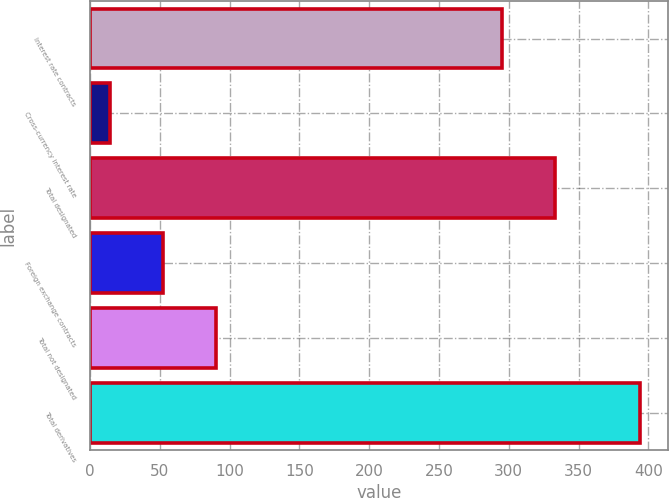Convert chart to OTSL. <chart><loc_0><loc_0><loc_500><loc_500><bar_chart><fcel>Interest rate contracts<fcel>Cross-currency interest rate<fcel>Total designated<fcel>Foreign exchange contracts<fcel>Total not designated<fcel>Total derivatives<nl><fcel>295<fcel>14<fcel>333<fcel>52<fcel>90<fcel>394<nl></chart> 